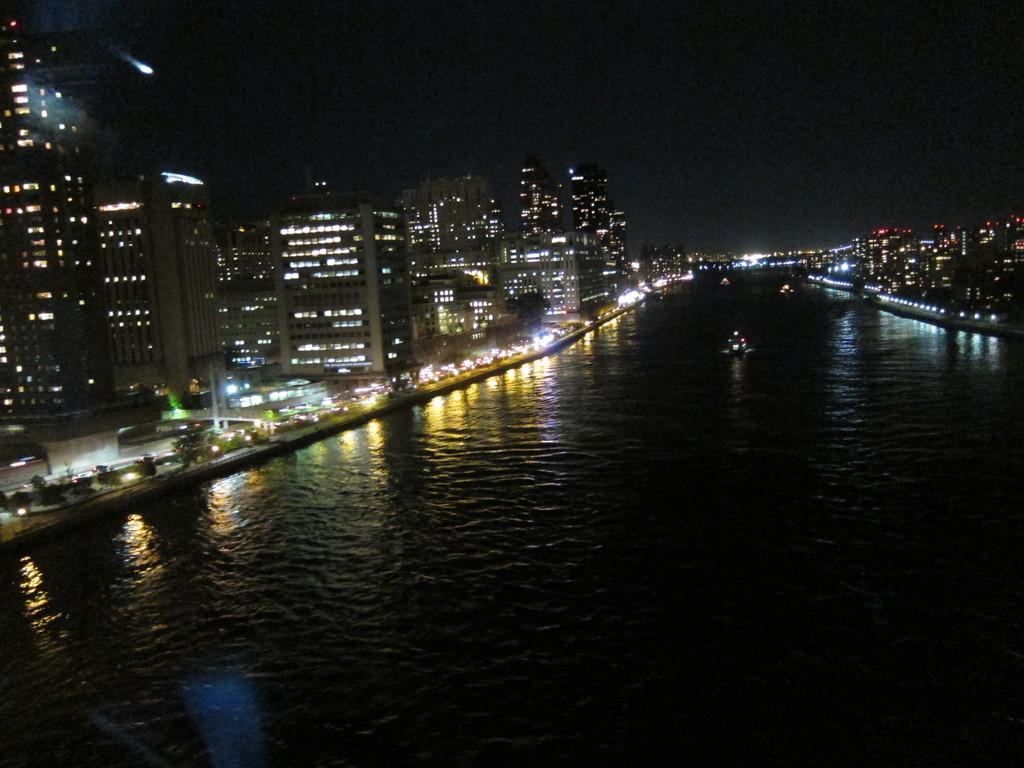In one or two sentences, can you explain what this image depicts? In this image we can see a lake. There are many buildings at the either sides of the image. We can see the dark sky in the image. We can see the reflections of lights on the water surface. There are few water crafts in the image. 